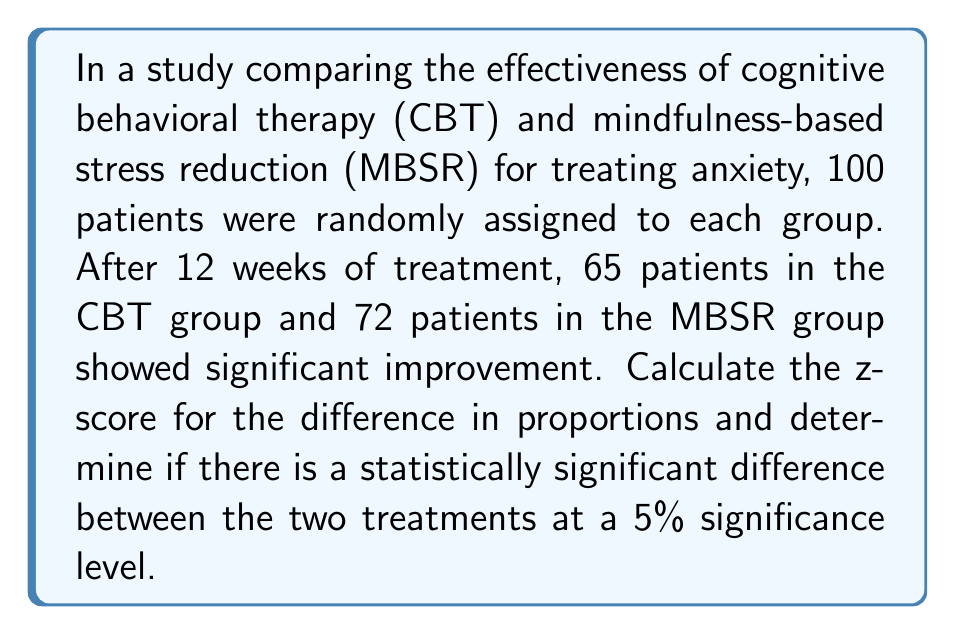Give your solution to this math problem. To determine if there is a statistically significant difference between the two treatments, we need to calculate the z-score for the difference in proportions and compare it to the critical value for a 5% significance level.

Step 1: Calculate the proportions for each group
CBT proportion: $p_1 = \frac{65}{100} = 0.65$
MBSR proportion: $p_2 = \frac{72}{100} = 0.72$

Step 2: Calculate the pooled proportion
$$p = \frac{65 + 72}{100 + 100} = \frac{137}{200} = 0.685$$

Step 3: Calculate the standard error of the difference in proportions
$$SE = \sqrt{p(1-p)(\frac{1}{n_1} + \frac{1}{n_2})} = \sqrt{0.685(1-0.685)(\frac{1}{100} + \frac{1}{100})} = 0.0657$$

Step 4: Calculate the z-score
$$z = \frac{p_2 - p_1}{SE} = \frac{0.72 - 0.65}{0.0657} = 1.0654$$

Step 5: Determine the critical value for a 5% significance level (two-tailed test)
The critical value for a 5% significance level (α = 0.05) in a two-tailed test is ±1.96.

Step 6: Compare the calculated z-score to the critical value
Since |1.0654| < 1.96, we fail to reject the null hypothesis.
Answer: z = 1.0654; Not statistically significant at 5% level 